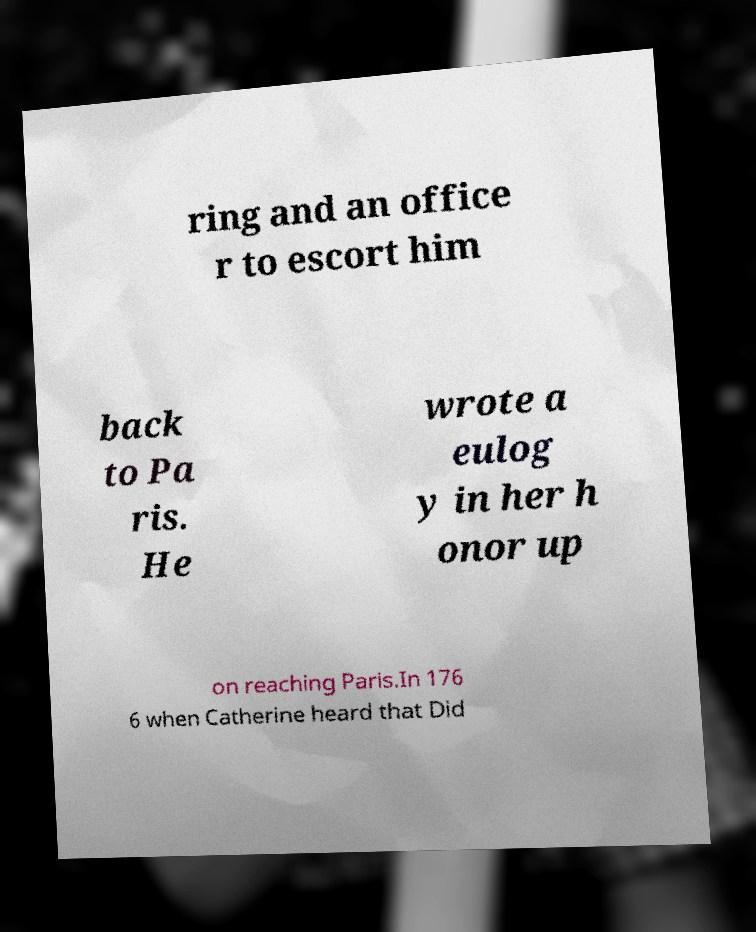There's text embedded in this image that I need extracted. Can you transcribe it verbatim? ring and an office r to escort him back to Pa ris. He wrote a eulog y in her h onor up on reaching Paris.In 176 6 when Catherine heard that Did 